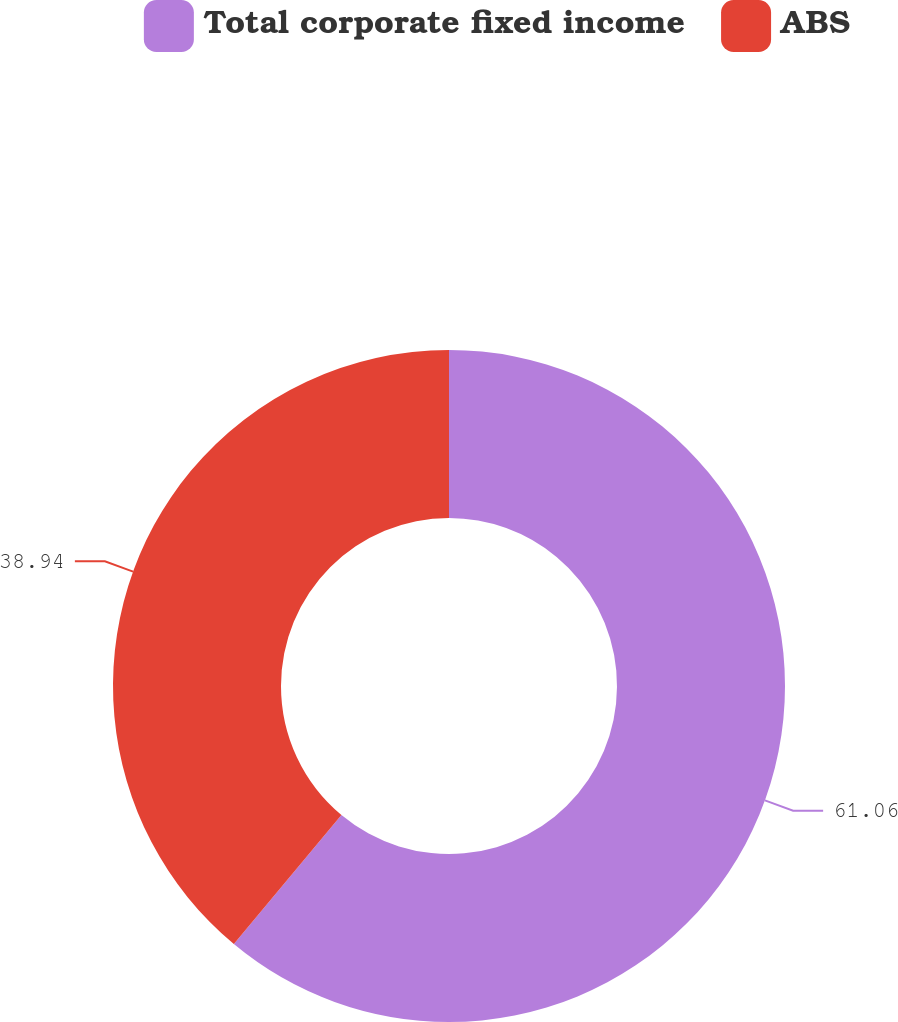Convert chart. <chart><loc_0><loc_0><loc_500><loc_500><pie_chart><fcel>Total corporate fixed income<fcel>ABS<nl><fcel>61.06%<fcel>38.94%<nl></chart> 